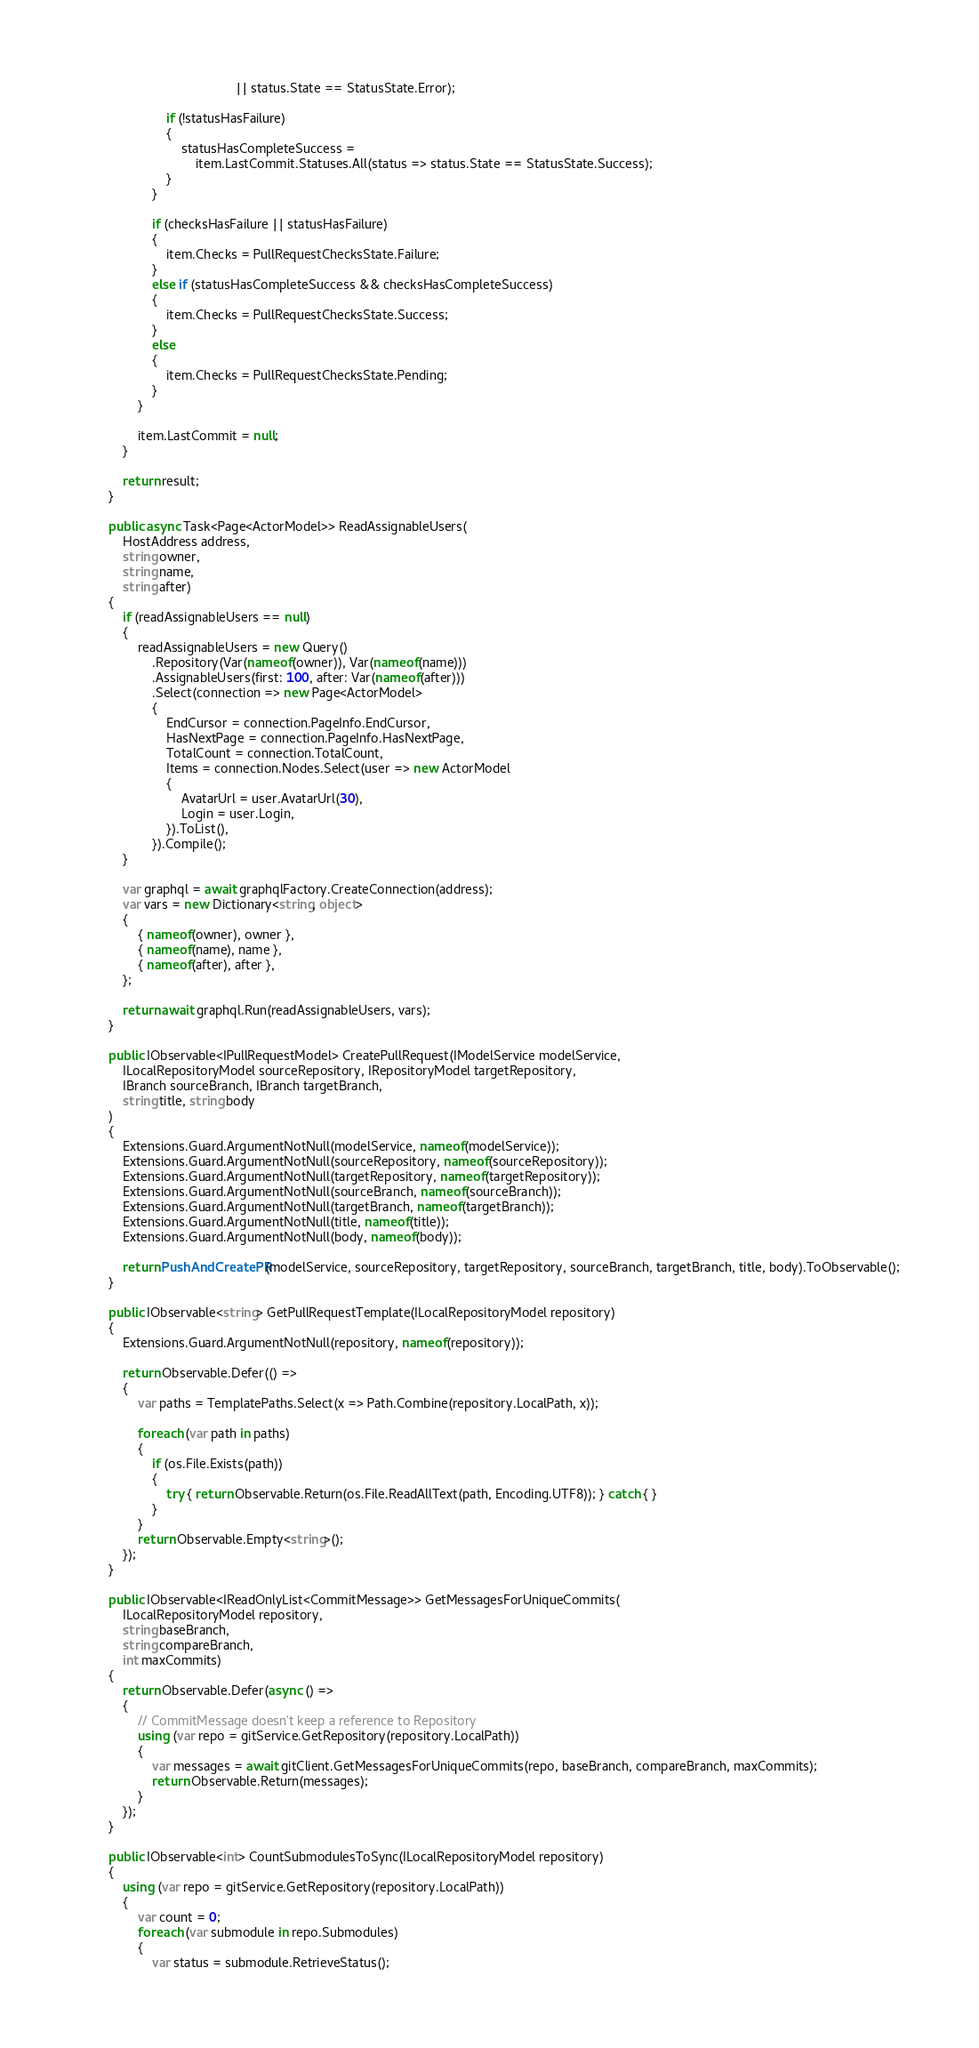Convert code to text. <code><loc_0><loc_0><loc_500><loc_500><_C#_>                                           || status.State == StatusState.Error);

                        if (!statusHasFailure)
                        {
                            statusHasCompleteSuccess =
                                item.LastCommit.Statuses.All(status => status.State == StatusState.Success);
                        }
                    }

                    if (checksHasFailure || statusHasFailure)
                    {
                        item.Checks = PullRequestChecksState.Failure;
                    }
                    else if (statusHasCompleteSuccess && checksHasCompleteSuccess)
                    {
                        item.Checks = PullRequestChecksState.Success;
                    }
                    else
                    {
                        item.Checks = PullRequestChecksState.Pending;
                    }
                }

                item.LastCommit = null;
            }

            return result;
        }

        public async Task<Page<ActorModel>> ReadAssignableUsers(
            HostAddress address,
            string owner,
            string name,
            string after)
        {
            if (readAssignableUsers == null)
            {
                readAssignableUsers = new Query()
                    .Repository(Var(nameof(owner)), Var(nameof(name)))
                    .AssignableUsers(first: 100, after: Var(nameof(after)))
                    .Select(connection => new Page<ActorModel>
                    {
                        EndCursor = connection.PageInfo.EndCursor,
                        HasNextPage = connection.PageInfo.HasNextPage,
                        TotalCount = connection.TotalCount,
                        Items = connection.Nodes.Select(user => new ActorModel
                        {
                            AvatarUrl = user.AvatarUrl(30),
                            Login = user.Login,
                        }).ToList(),
                    }).Compile();
            }

            var graphql = await graphqlFactory.CreateConnection(address);
            var vars = new Dictionary<string, object>
            {
                { nameof(owner), owner },
                { nameof(name), name },
                { nameof(after), after },
            };

            return await graphql.Run(readAssignableUsers, vars);
        }

        public IObservable<IPullRequestModel> CreatePullRequest(IModelService modelService,
            ILocalRepositoryModel sourceRepository, IRepositoryModel targetRepository,
            IBranch sourceBranch, IBranch targetBranch,
            string title, string body
        )
        {
            Extensions.Guard.ArgumentNotNull(modelService, nameof(modelService));
            Extensions.Guard.ArgumentNotNull(sourceRepository, nameof(sourceRepository));
            Extensions.Guard.ArgumentNotNull(targetRepository, nameof(targetRepository));
            Extensions.Guard.ArgumentNotNull(sourceBranch, nameof(sourceBranch));
            Extensions.Guard.ArgumentNotNull(targetBranch, nameof(targetBranch));
            Extensions.Guard.ArgumentNotNull(title, nameof(title));
            Extensions.Guard.ArgumentNotNull(body, nameof(body));

            return PushAndCreatePR(modelService, sourceRepository, targetRepository, sourceBranch, targetBranch, title, body).ToObservable();
        }

        public IObservable<string> GetPullRequestTemplate(ILocalRepositoryModel repository)
        {
            Extensions.Guard.ArgumentNotNull(repository, nameof(repository));

            return Observable.Defer(() =>
            {
                var paths = TemplatePaths.Select(x => Path.Combine(repository.LocalPath, x));

                foreach (var path in paths)
                {
                    if (os.File.Exists(path))
                    {
                        try { return Observable.Return(os.File.ReadAllText(path, Encoding.UTF8)); } catch { }
                    }
                }
                return Observable.Empty<string>();
            });
        }

        public IObservable<IReadOnlyList<CommitMessage>> GetMessagesForUniqueCommits(
            ILocalRepositoryModel repository,
            string baseBranch,
            string compareBranch,
            int maxCommits)
        {
            return Observable.Defer(async () =>
            {
                // CommitMessage doesn't keep a reference to Repository
                using (var repo = gitService.GetRepository(repository.LocalPath))
                {
                    var messages = await gitClient.GetMessagesForUniqueCommits(repo, baseBranch, compareBranch, maxCommits);
                    return Observable.Return(messages);
                }
            });
        }

        public IObservable<int> CountSubmodulesToSync(ILocalRepositoryModel repository)
        {
            using (var repo = gitService.GetRepository(repository.LocalPath))
            {
                var count = 0;
                foreach (var submodule in repo.Submodules)
                {
                    var status = submodule.RetrieveStatus();</code> 